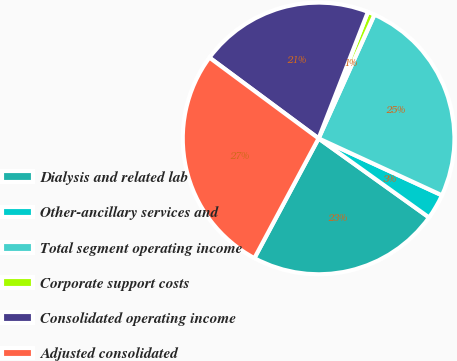Convert chart to OTSL. <chart><loc_0><loc_0><loc_500><loc_500><pie_chart><fcel>Dialysis and related lab<fcel>Other-ancillary services and<fcel>Total segment operating income<fcel>Corporate support costs<fcel>Consolidated operating income<fcel>Adjusted consolidated<nl><fcel>22.95%<fcel>3.01%<fcel>25.13%<fcel>0.83%<fcel>20.77%<fcel>27.31%<nl></chart> 